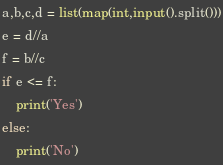<code> <loc_0><loc_0><loc_500><loc_500><_Python_>a,b,c,d = list(map(int,input().split()))
e = d//a
f = b//c
if e <= f:
    print('Yes')
else:
    print('No')</code> 